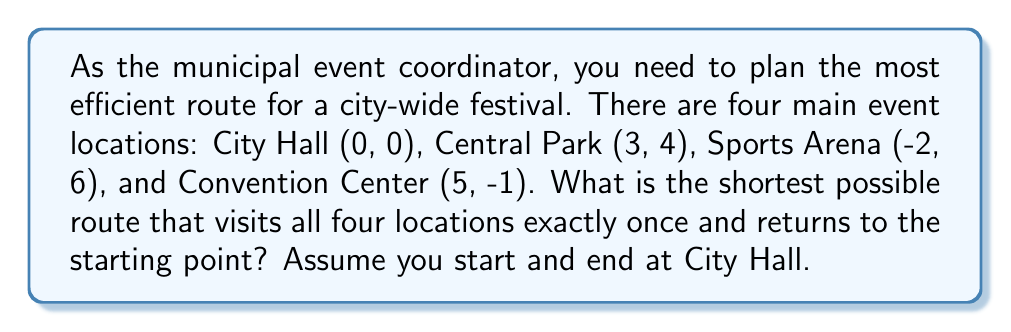Can you solve this math problem? To solve this problem, we need to:
1. Calculate the distances between all pairs of locations
2. Find all possible routes
3. Calculate the total distance for each route
4. Determine the shortest route

Step 1: Calculate distances using the distance formula
$$d = \sqrt{(x_2-x_1)^2 + (y_2-y_1)^2}$$

CH to CP: $\sqrt{(3-0)^2 + (4-0)^2} = 5$
CH to SA: $\sqrt{(-2-0)^2 + (6-0)^2} = \sqrt{40} \approx 6.32$
CH to CC: $\sqrt{(5-0)^2 + (-1-0)^2} = \sqrt{26} \approx 5.10$
CP to SA: $\sqrt{(-2-3)^2 + (6-4)^2} = 5.39$
CP to CC: $\sqrt{(5-3)^2 + (-1-4)^2} = \sqrt{29} \approx 5.39$
SA to CC: $\sqrt{(5-(-2))^2 + (-1-6)^2} = \sqrt{106} \approx 10.30$

Step 2: Possible routes (starting and ending at CH)
1. CH → CP → SA → CC → CH
2. CH → CP → CC → SA → CH
3. CH → SA → CP → CC → CH
4. CH → SA → CC → CP → CH
5. CH → CC → CP → SA → CH
6. CH → CC → SA → CP → CH

Step 3: Calculate total distance for each route
1. 5 + 5.39 + 10.30 + 5.10 = 25.79
2. 5 + 5.39 + 10.30 + 6.32 = 27.01
3. 6.32 + 5.39 + 5.39 + 5.10 = 22.20
4. 6.32 + 10.30 + 5.39 + 5 = 27.01
5. 5.10 + 5.39 + 5.39 + 6.32 = 22.20
6. 5.10 + 10.30 + 5.39 + 5 = 25.79

Step 4: The shortest route is either 3 or 5, both with a total distance of 22.20 units.

[asy]
unitsize(30);
dot((0,0)); dot((3,4)); dot((-2,6)); dot((5,-1));
label("City Hall (CH)", (0,0), SW);
label("Central Park (CP)", (3,4), NE);
label("Sports Arena (SA)", (-2,6), NW);
label("Convention Center (CC)", (5,-1), SE);
draw((0,0)--(3,4)--(-2,6)--(5,-1)--cycle, arrow=Arrow(TeXHead));
[/asy]
Answer: CH → SA → CP → CC → CH, distance: 22.20 units 